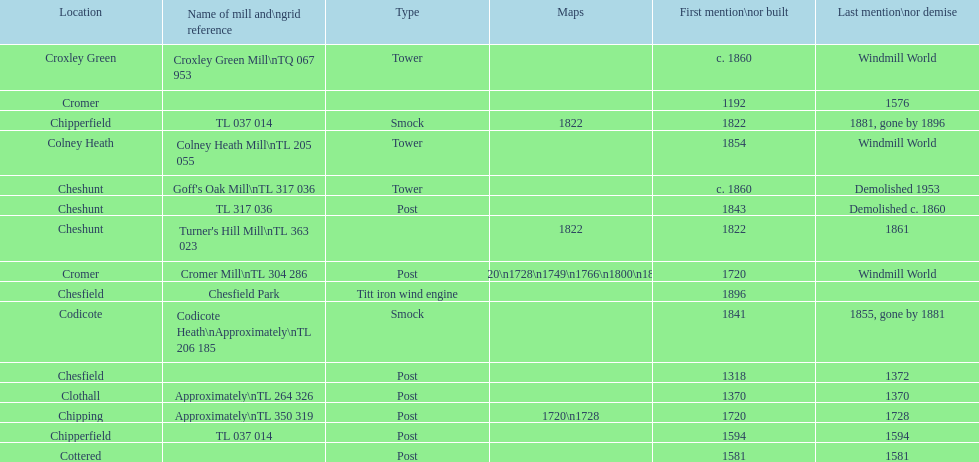What location has the most maps? Cromer. 